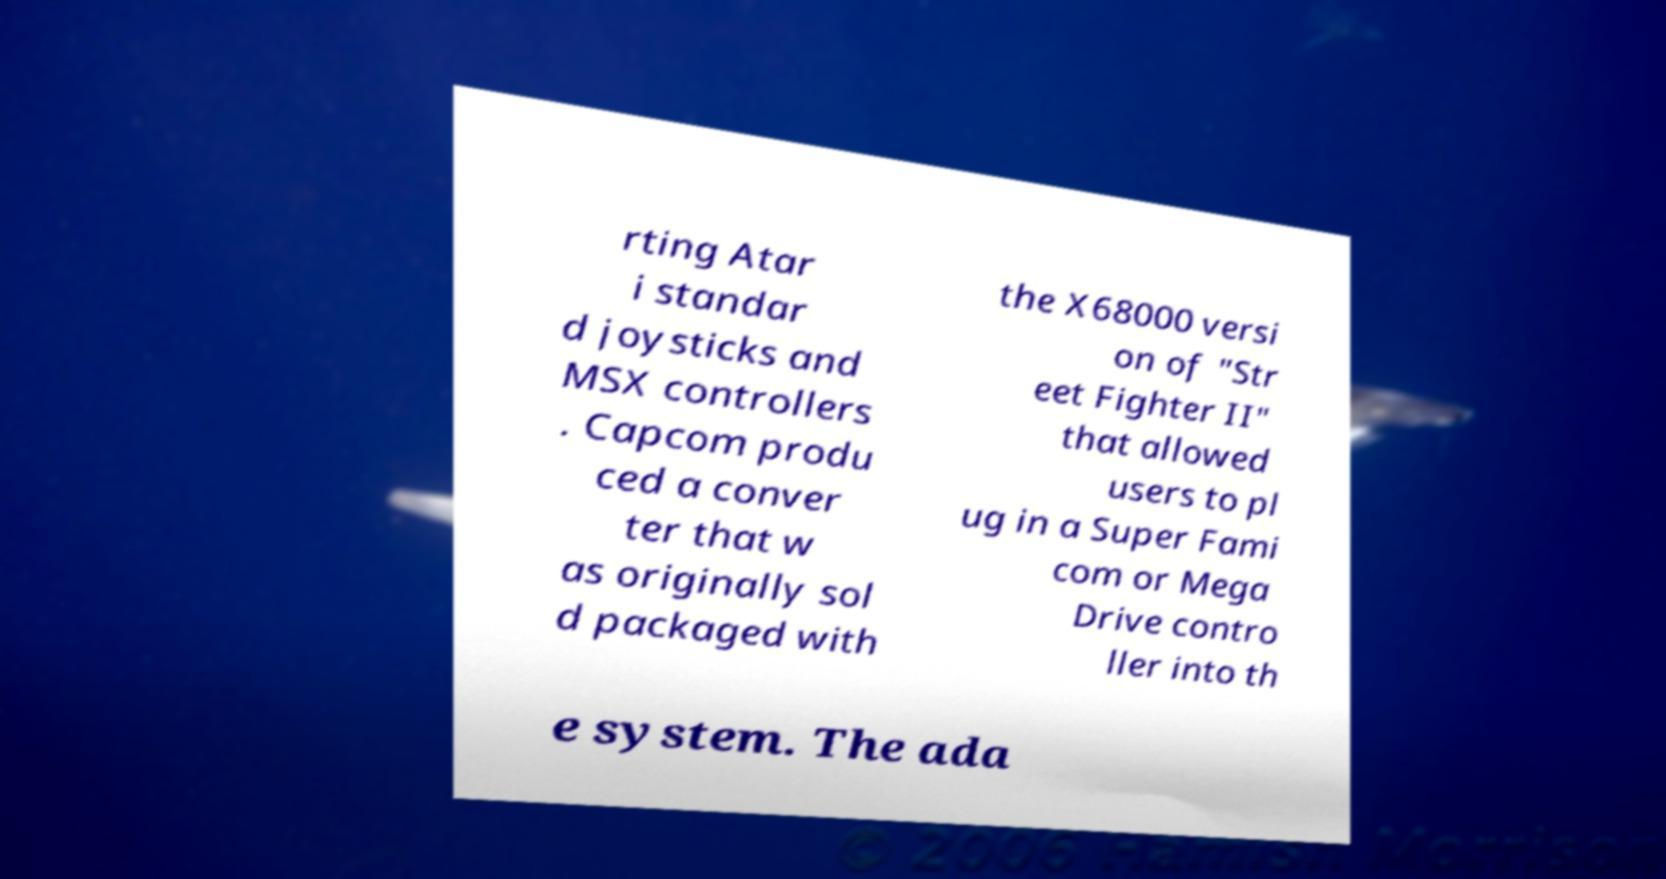There's text embedded in this image that I need extracted. Can you transcribe it verbatim? rting Atar i standar d joysticks and MSX controllers . Capcom produ ced a conver ter that w as originally sol d packaged with the X68000 versi on of "Str eet Fighter II" that allowed users to pl ug in a Super Fami com or Mega Drive contro ller into th e system. The ada 